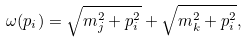<formula> <loc_0><loc_0><loc_500><loc_500>\omega ( p _ { i } ) = \sqrt { m _ { j } ^ { 2 } + p _ { i } ^ { 2 } } + \sqrt { m _ { k } ^ { 2 } + p _ { i } ^ { 2 } } ,</formula> 